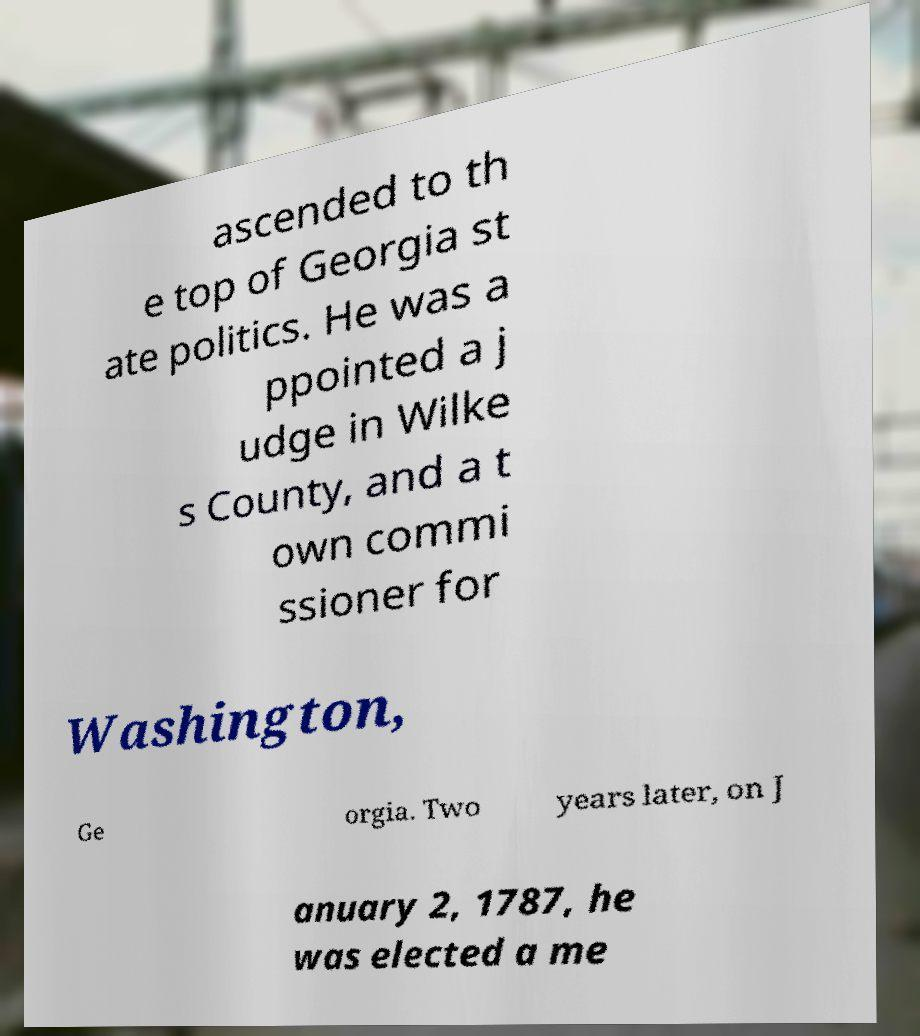I need the written content from this picture converted into text. Can you do that? ascended to th e top of Georgia st ate politics. He was a ppointed a j udge in Wilke s County, and a t own commi ssioner for Washington, Ge orgia. Two years later, on J anuary 2, 1787, he was elected a me 